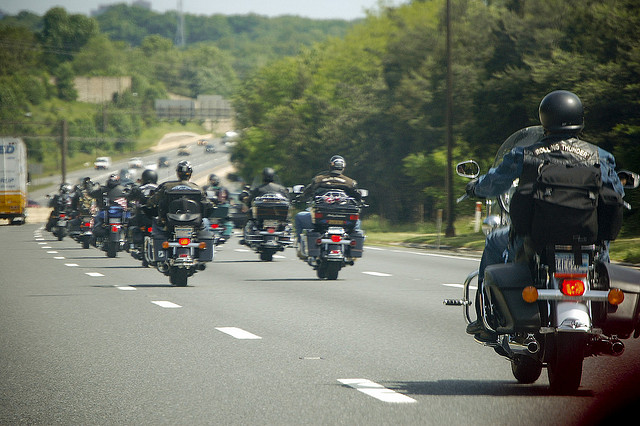<image>What is the license plate number? It is unknown what the license plate number is, as there are many different possible answers such as '401ks', 'meg 690', '84e698', '2134775', '496', '14fg96', '74fg98', and '1235'. What color is the parking lot stripe? There is no parking lot in the image. However, the stripe could be white. What color is the parking lot stripe? The color of the parking lot stripe is white. What is the license plate number? I don't know the license plate number. It can be seen '401ks', 'meg 690', '84e698', '2134775', '496', '14fg96', '74fg98', or '1235'. 